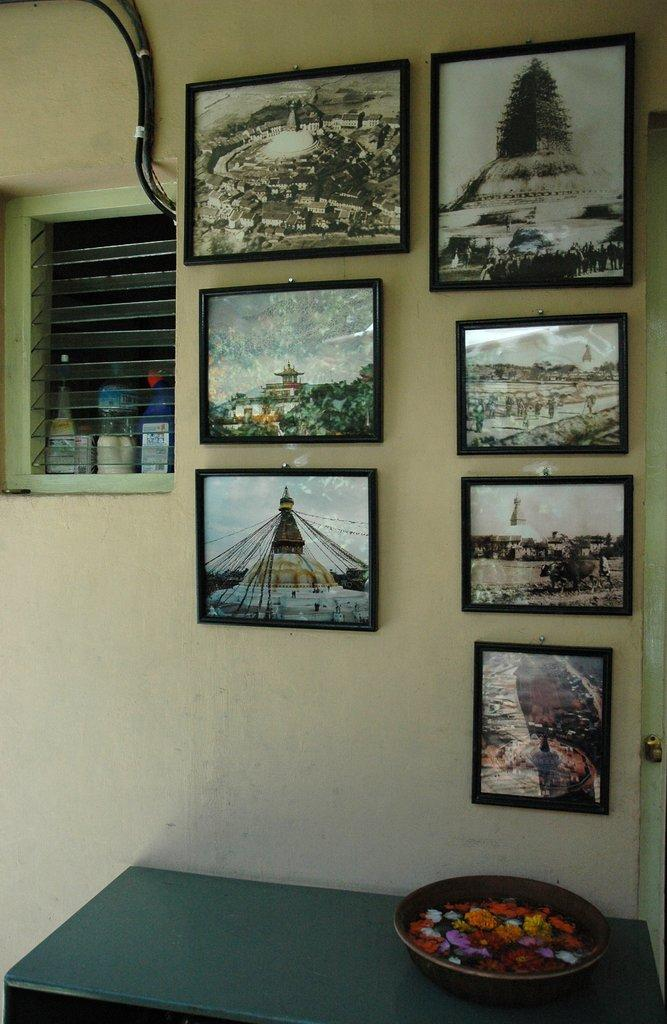What is the main object in the center of the image? There is a table in the center of the image. What is placed on the table? There is a bowl with flowers on the table. What can be seen in the background of the image? There is a photo frame, a window, and a wall in the background of the image. What type of jeans is the person wearing in the image? There is no person present in the image, and therefore no clothing can be observed. 